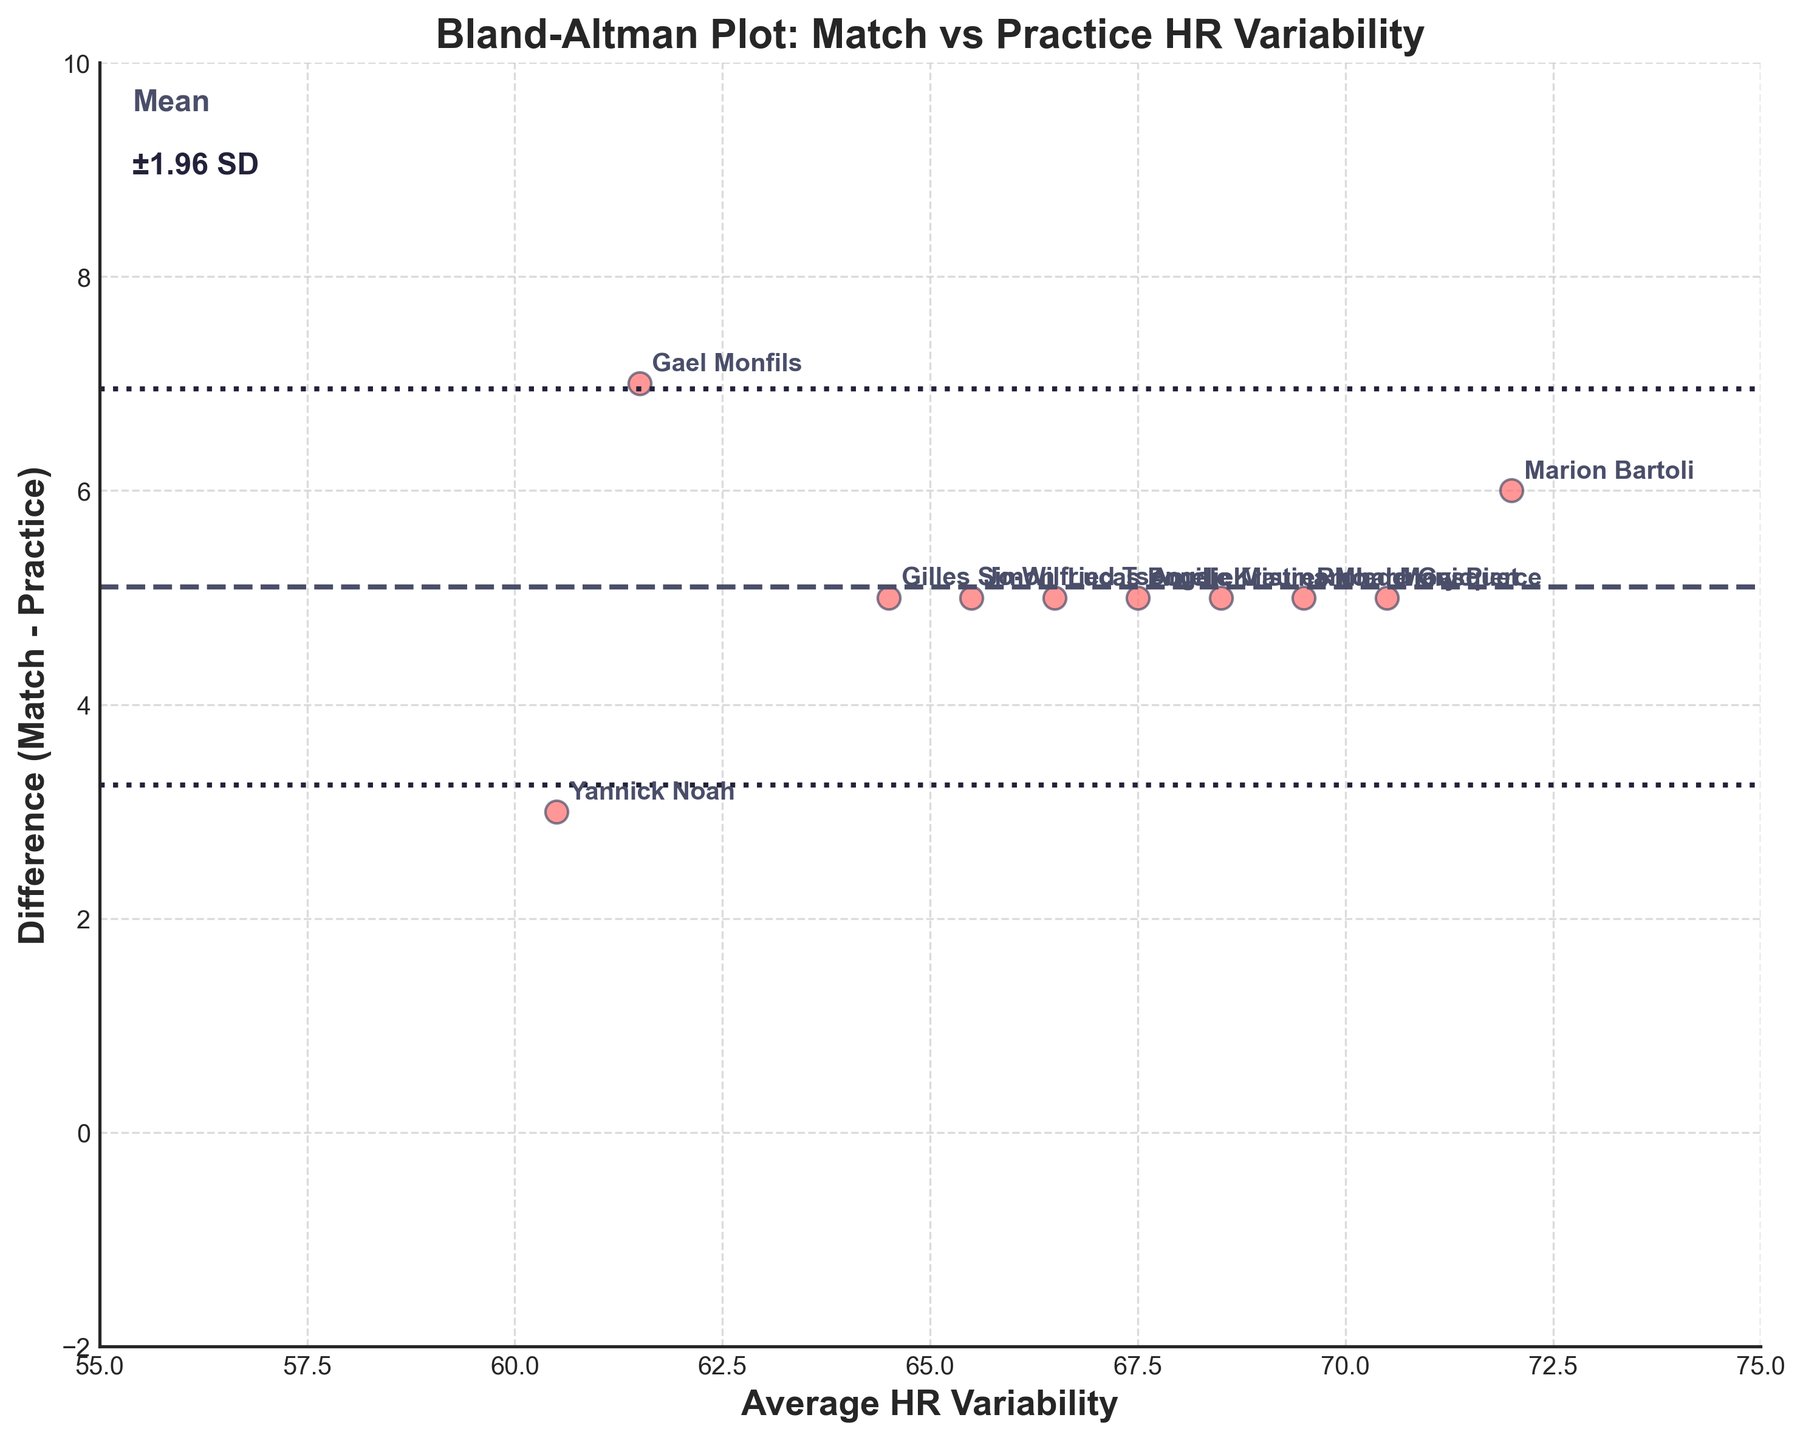What is the title of the plot? The title is always placed at the top of the plot to describe what the visualization is about. In this case, it is clearly written at the top.
Answer: Bland-Altman Plot: Match vs Practice HR Variability How many data points are displayed in the plot? Count the number of scattered points in the plot. Each point corresponds to one player's data.
Answer: 10 Which player has the highest Match HR Variability? Look for the player label with the highest Average HR Variability since that indicates a higher value closer to the match HR variability when the differences are relatively small.
Answer: Marion Bartoli What are the limits of agreement in this plot? Limits of agreement are marked by dotted lines and are calculated as Mean ± 1.96*Standard Deviation (SD). Look at the plot to find the values of these lines.
Answer: Mean diff ± ~2SD What is the difference in HR Variability between Match and Practice for Gilles Simon? Identify Gilles Simon's point on the plot, then check its y-axis value to find the difference between Match and Practice HR Variability.
Answer: 5 Is the mean difference greater than 0? Check the horizontal line representing the mean difference; it is above the x-axis indicating it is greater than 0.
Answer: Yes Which player shows the largest difference in HR Variability between match and practice sessions? The largest difference corresponds to the highest point on the y-axis. Find the highest point and its associated player label.
Answer: Gael Monfils What's the standard deviation of the differences? Use the plot’s limits of agreement centered around the mean; since the limits are at Mean ± 1.96 SD, divide the span between the limits by 3.92 (2 * 1.96) to find the SD.
Answer: Approximately 1.44 How many players have a difference of exactly 5 in HR Variability? Count all the labels corresponding to points on the horizontal line at y = 5.
Answer: 7 